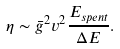<formula> <loc_0><loc_0><loc_500><loc_500>\eta \sim \bar { g } ^ { 2 } v ^ { 2 } \frac { E _ { s p e n t } } { \Delta E } .</formula> 